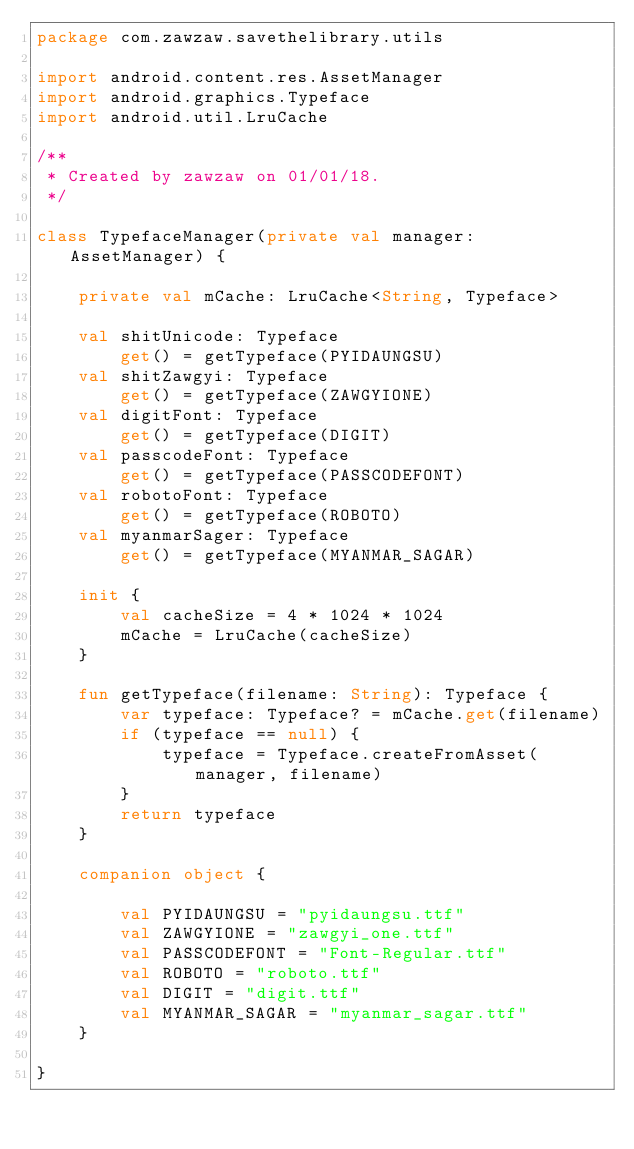<code> <loc_0><loc_0><loc_500><loc_500><_Kotlin_>package com.zawzaw.savethelibrary.utils

import android.content.res.AssetManager
import android.graphics.Typeface
import android.util.LruCache

/**
 * Created by zawzaw on 01/01/18.
 */

class TypefaceManager(private val manager: AssetManager) {

    private val mCache: LruCache<String, Typeface>

    val shitUnicode: Typeface
        get() = getTypeface(PYIDAUNGSU)
    val shitZawgyi: Typeface
        get() = getTypeface(ZAWGYIONE)
    val digitFont: Typeface
        get() = getTypeface(DIGIT)
    val passcodeFont: Typeface
        get() = getTypeface(PASSCODEFONT)
    val robotoFont: Typeface
        get() = getTypeface(ROBOTO)
    val myanmarSager: Typeface
        get() = getTypeface(MYANMAR_SAGAR)

    init {
        val cacheSize = 4 * 1024 * 1024
        mCache = LruCache(cacheSize)
    }

    fun getTypeface(filename: String): Typeface {
        var typeface: Typeface? = mCache.get(filename)
        if (typeface == null) {
            typeface = Typeface.createFromAsset(manager, filename)
        }
        return typeface
    }

    companion object {

        val PYIDAUNGSU = "pyidaungsu.ttf"
        val ZAWGYIONE = "zawgyi_one.ttf"
        val PASSCODEFONT = "Font-Regular.ttf"
        val ROBOTO = "roboto.ttf"
        val DIGIT = "digit.ttf"
        val MYANMAR_SAGAR = "myanmar_sagar.ttf"
    }

}
</code> 